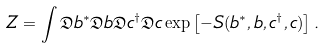Convert formula to latex. <formula><loc_0><loc_0><loc_500><loc_500>Z = \int \mathfrak { D } b ^ { * } \mathfrak { D } b \mathfrak { D } c ^ { \dag } \mathfrak { D } c \exp \left [ - S ( b ^ { * } , b , c ^ { \dag } , c ) \right ] .</formula> 